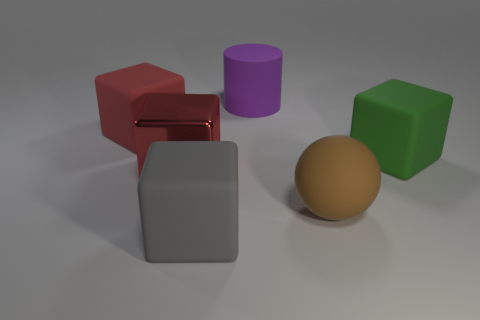Add 4 rubber cylinders. How many objects exist? 10 Subtract all gray matte blocks. How many blocks are left? 3 Subtract all purple cylinders. How many red cubes are left? 2 Subtract all green blocks. How many blocks are left? 3 Subtract 1 cylinders. How many cylinders are left? 0 Subtract all cylinders. How many objects are left? 5 Add 2 big things. How many big things are left? 8 Add 3 red matte cubes. How many red matte cubes exist? 4 Subtract 1 purple cylinders. How many objects are left? 5 Subtract all red blocks. Subtract all yellow cylinders. How many blocks are left? 2 